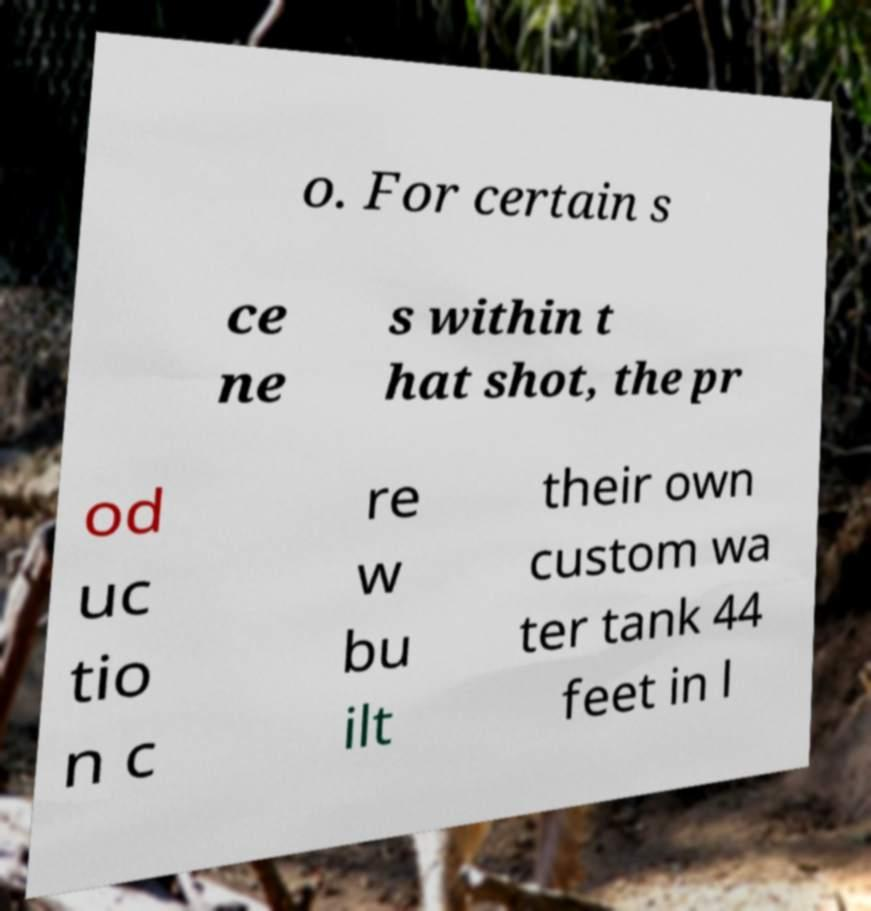There's text embedded in this image that I need extracted. Can you transcribe it verbatim? o. For certain s ce ne s within t hat shot, the pr od uc tio n c re w bu ilt their own custom wa ter tank 44 feet in l 